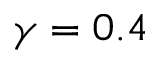Convert formula to latex. <formula><loc_0><loc_0><loc_500><loc_500>\gamma = 0 . 4</formula> 